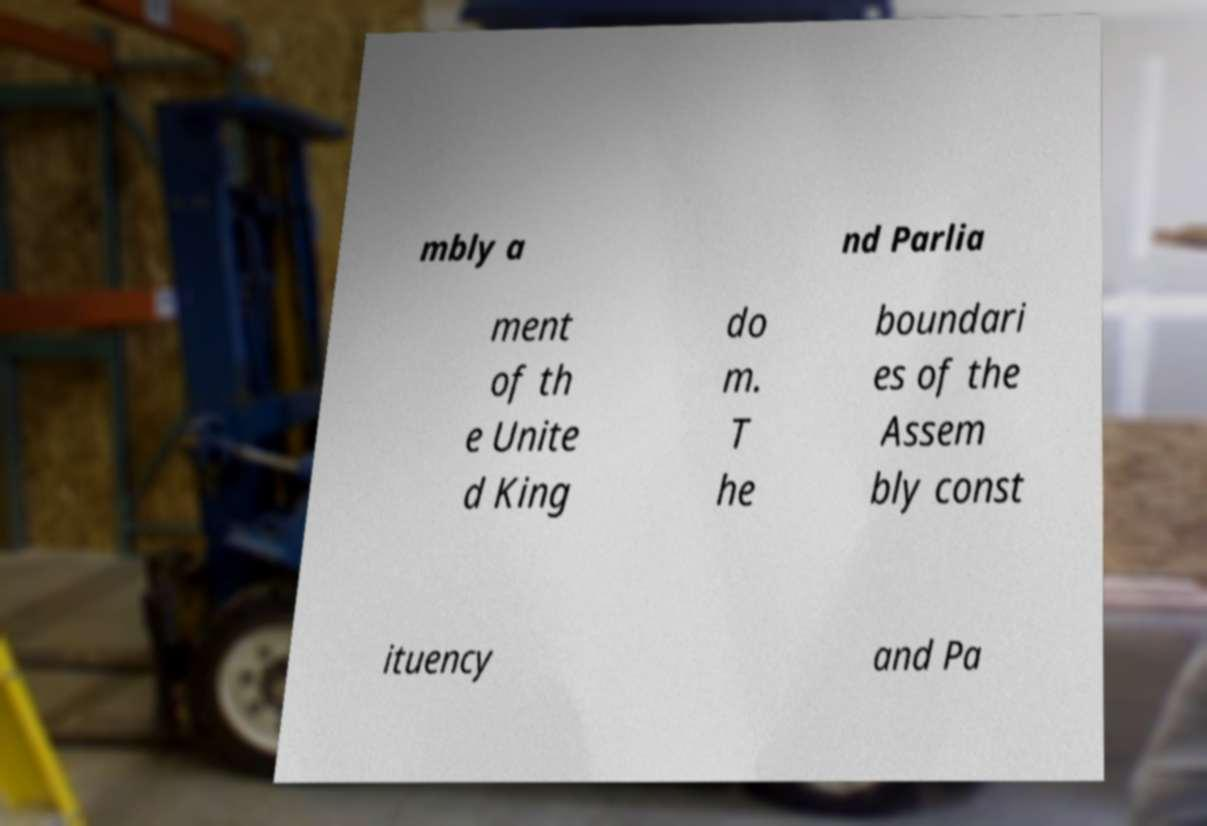Please identify and transcribe the text found in this image. mbly a nd Parlia ment of th e Unite d King do m. T he boundari es of the Assem bly const ituency and Pa 